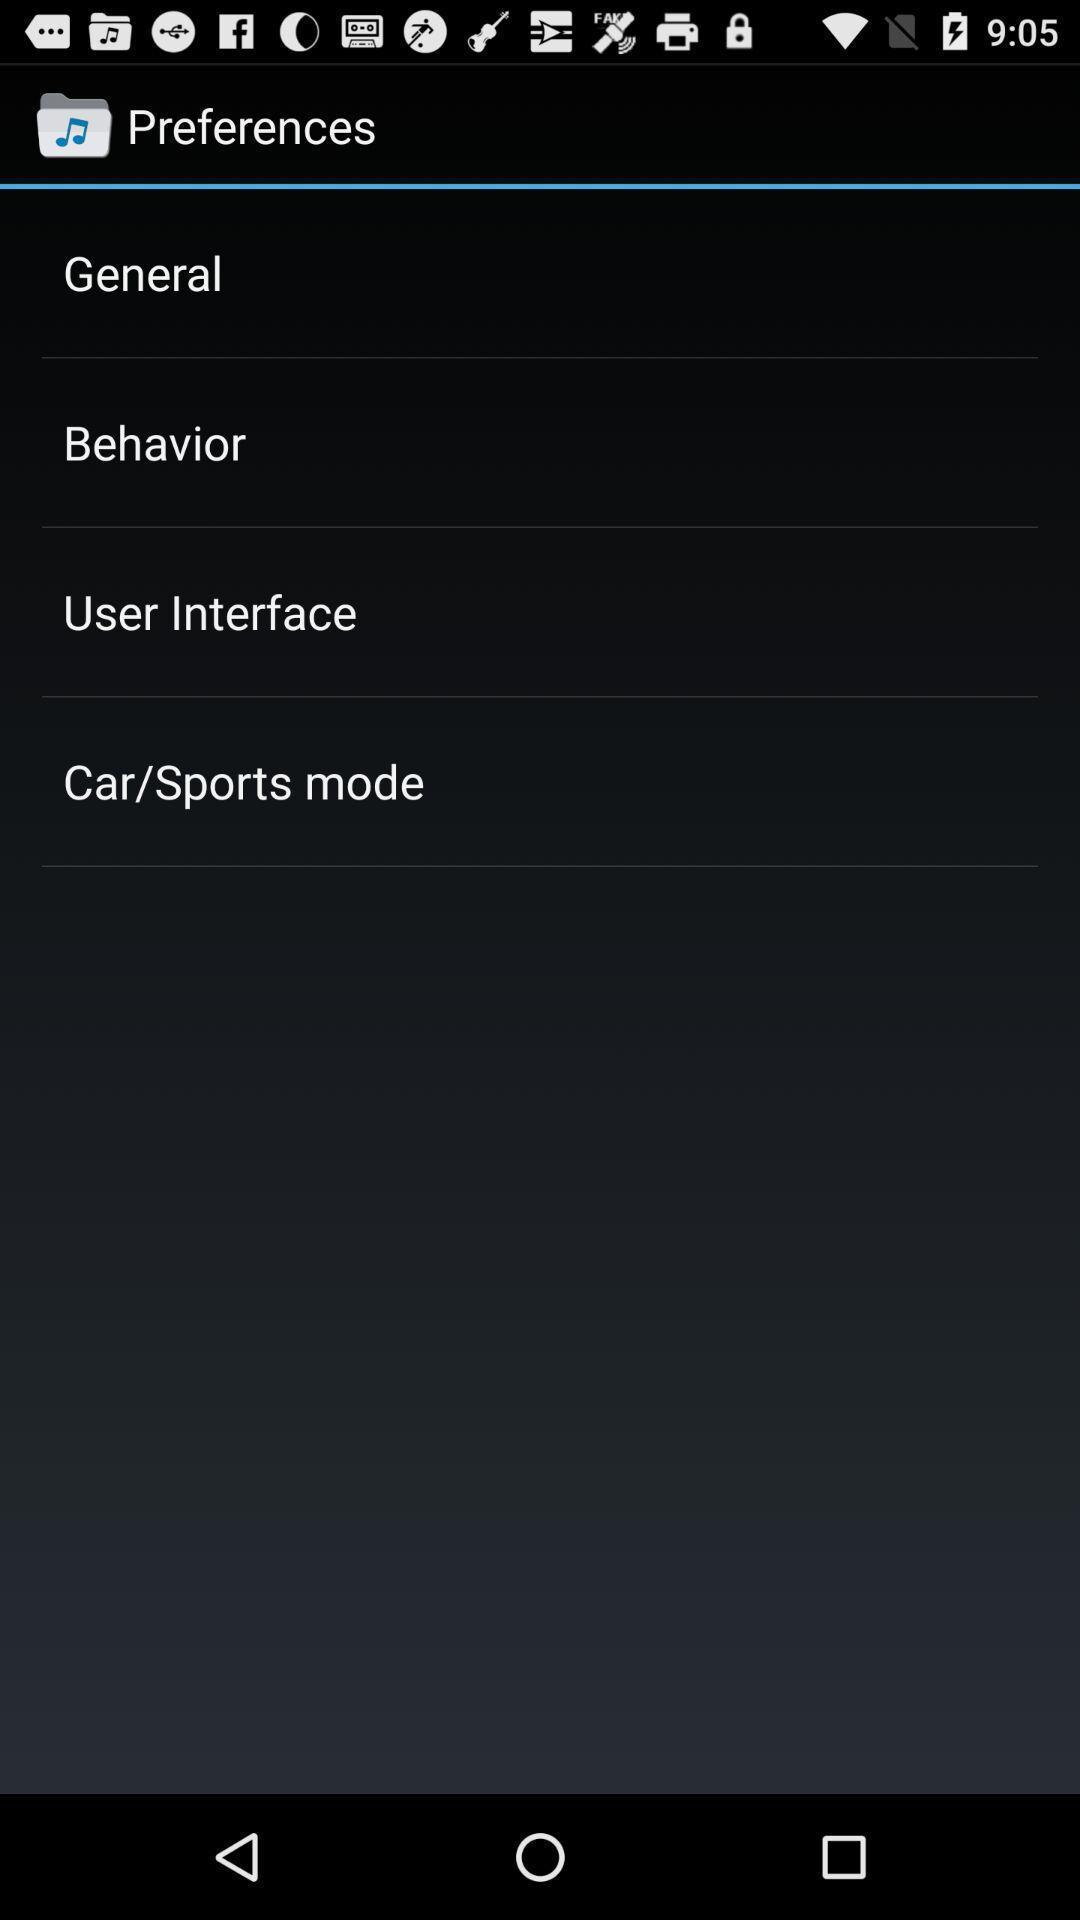Tell me what you see in this picture. Screen displaying the preferences page. 